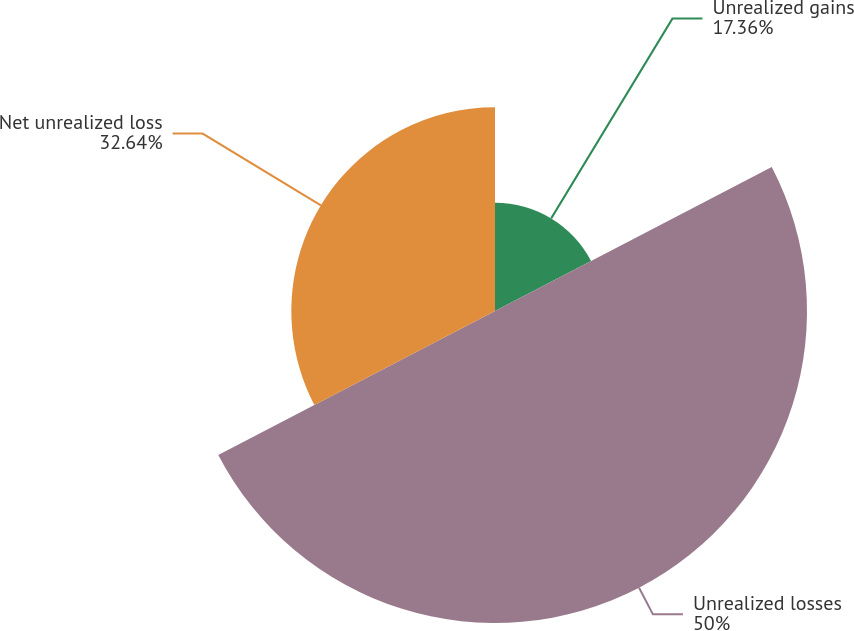Convert chart to OTSL. <chart><loc_0><loc_0><loc_500><loc_500><pie_chart><fcel>Unrealized gains<fcel>Unrealized losses<fcel>Net unrealized loss<nl><fcel>17.36%<fcel>50.0%<fcel>32.64%<nl></chart> 